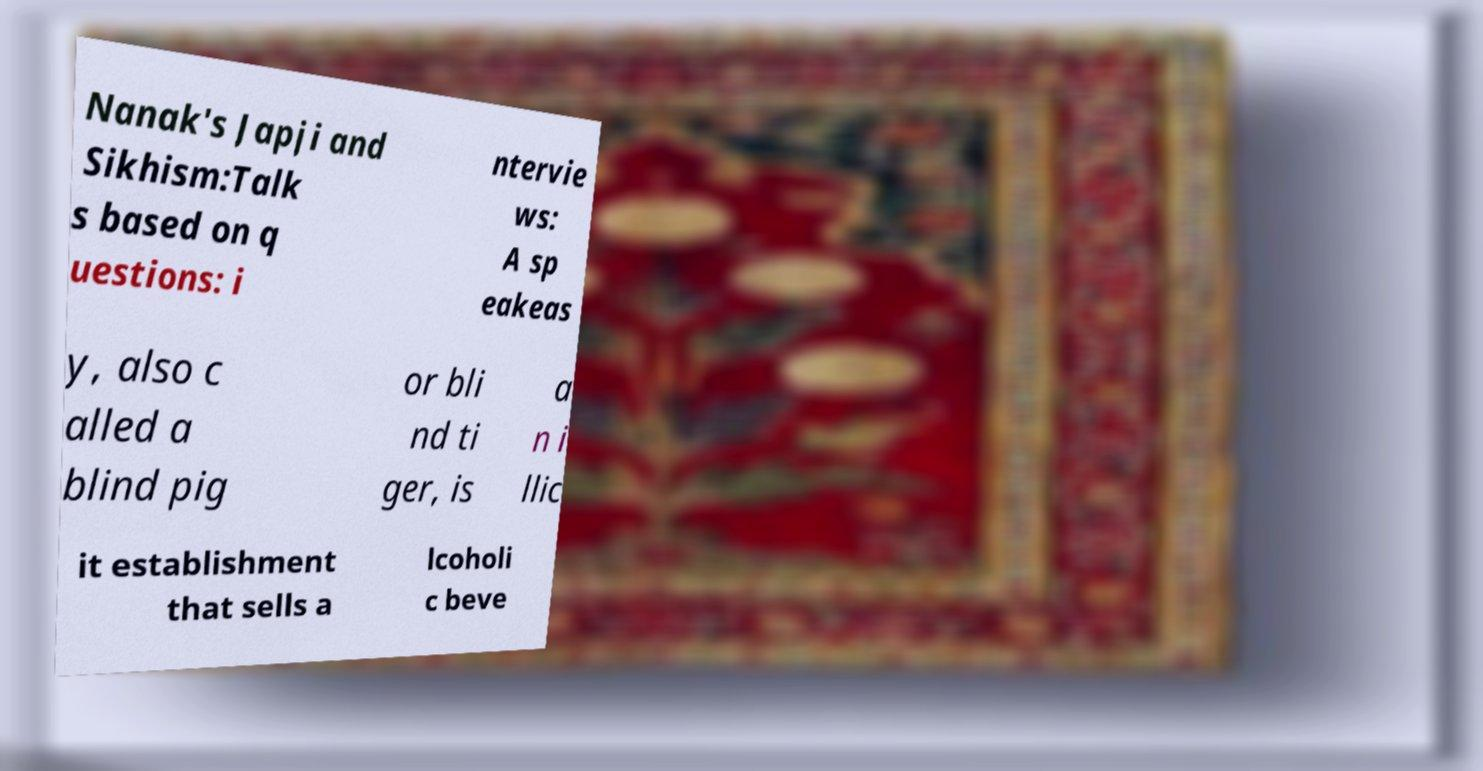Could you extract and type out the text from this image? Nanak's Japji and Sikhism:Talk s based on q uestions: i ntervie ws: A sp eakeas y, also c alled a blind pig or bli nd ti ger, is a n i llic it establishment that sells a lcoholi c beve 